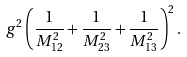Convert formula to latex. <formula><loc_0><loc_0><loc_500><loc_500>g ^ { 2 } \left ( \frac { 1 } { M _ { 1 2 } ^ { 2 } } + \frac { 1 } { M _ { 2 3 } ^ { 2 } } + \frac { 1 } { M _ { 1 3 } ^ { 2 } } \right ) ^ { 2 } .</formula> 